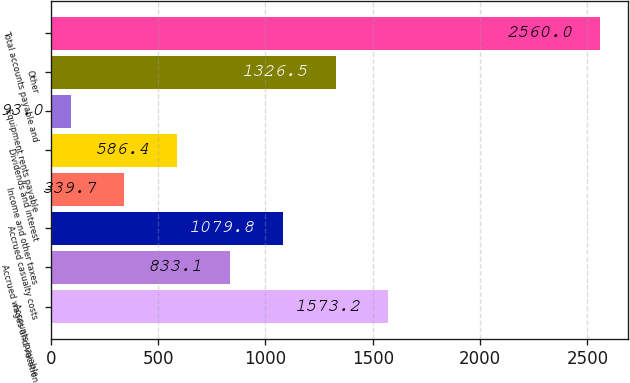Convert chart to OTSL. <chart><loc_0><loc_0><loc_500><loc_500><bar_chart><fcel>Accounts payable<fcel>Accrued wages and vacation<fcel>Accrued casualty costs<fcel>Income and other taxes<fcel>Dividends and interest<fcel>Equipment rents payable<fcel>Other<fcel>Total accounts payable and<nl><fcel>1573.2<fcel>833.1<fcel>1079.8<fcel>339.7<fcel>586.4<fcel>93<fcel>1326.5<fcel>2560<nl></chart> 